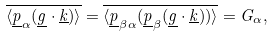<formula> <loc_0><loc_0><loc_500><loc_500>\overline { \langle \underline { p } _ { \alpha } ( \underline { g } \cdot \underline { k } ) \rangle } = \overline { \langle \underline { p } _ { \beta \alpha } ( \underline { p } _ { \beta } ( \underline { g } \cdot \underline { k } ) ) \rangle } = G _ { \alpha } ,</formula> 